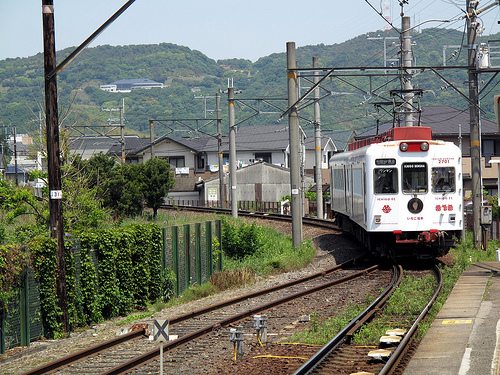<image>
Can you confirm if the train is on the train tracks? Yes. Looking at the image, I can see the train is positioned on top of the train tracks, with the train tracks providing support. 